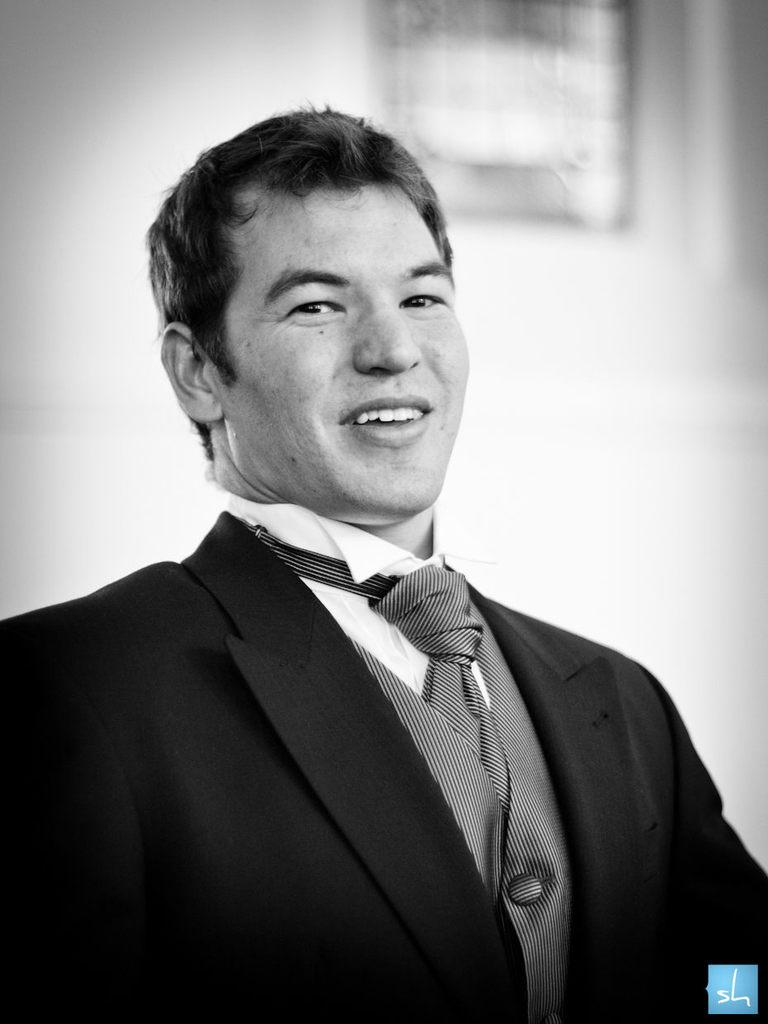What is the main subject of the image? The main subject of the image is a man. What is the man wearing in the image? The man is wearing a blazer and a tie in the image. What is the man's facial expression in the image? The man is smiling in the image. Can you describe the background of the image? The background of the image is blurry. What type of expert can be seen in the cemetery in the image? There is no expert or cemetery present in the image; it features a man wearing a blazer and a tie, smiling, with a blurry background. 